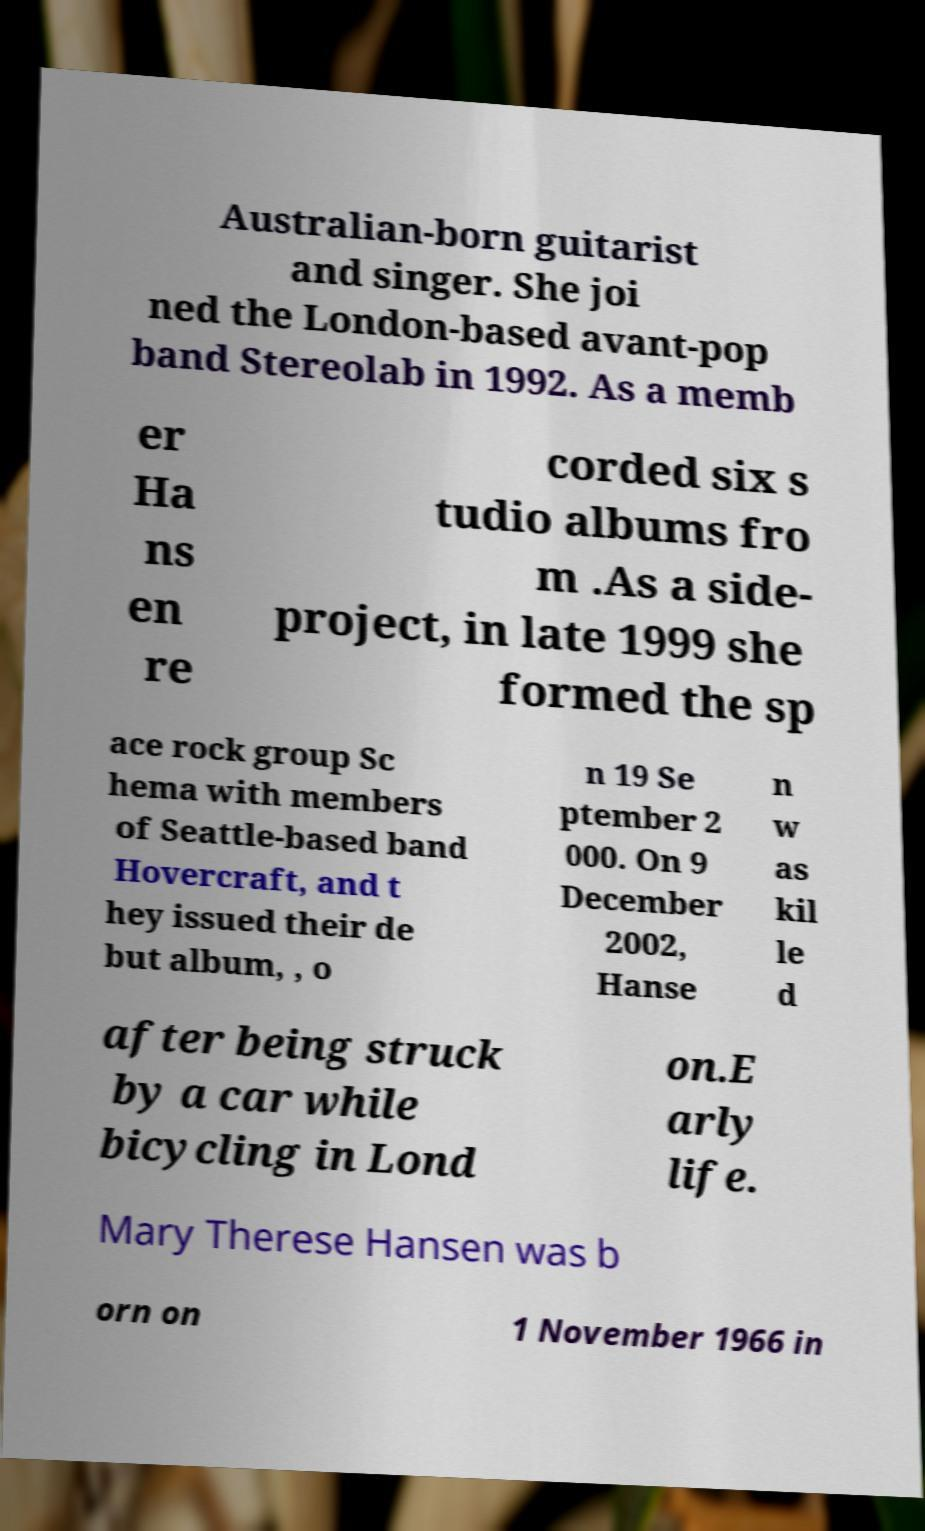Can you read and provide the text displayed in the image?This photo seems to have some interesting text. Can you extract and type it out for me? Australian-born guitarist and singer. She joi ned the London-based avant-pop band Stereolab in 1992. As a memb er Ha ns en re corded six s tudio albums fro m .As a side- project, in late 1999 she formed the sp ace rock group Sc hema with members of Seattle-based band Hovercraft, and t hey issued their de but album, , o n 19 Se ptember 2 000. On 9 December 2002, Hanse n w as kil le d after being struck by a car while bicycling in Lond on.E arly life. Mary Therese Hansen was b orn on 1 November 1966 in 